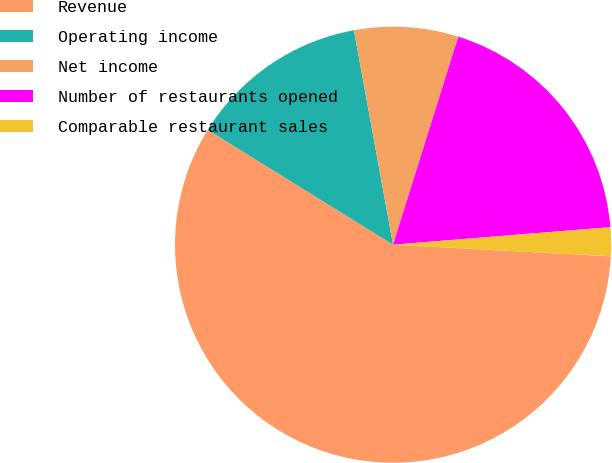Convert chart. <chart><loc_0><loc_0><loc_500><loc_500><pie_chart><fcel>Revenue<fcel>Operating income<fcel>Net income<fcel>Number of restaurants opened<fcel>Comparable restaurant sales<nl><fcel>57.98%<fcel>13.3%<fcel>7.71%<fcel>18.88%<fcel>2.13%<nl></chart> 